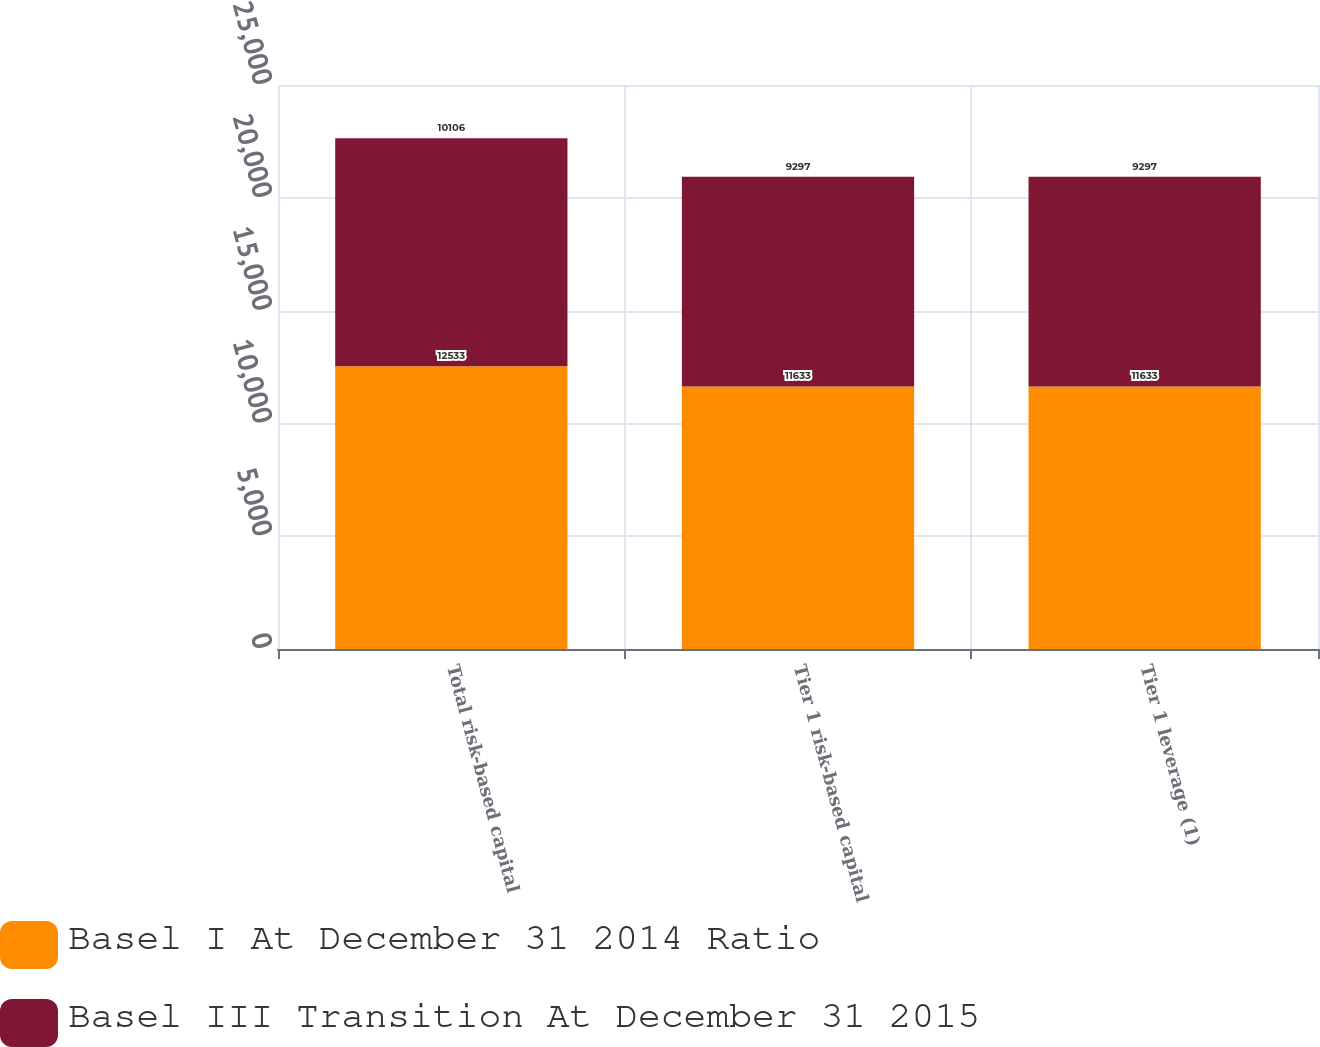Convert chart. <chart><loc_0><loc_0><loc_500><loc_500><stacked_bar_chart><ecel><fcel>Total risk-based capital<fcel>Tier 1 risk-based capital<fcel>Tier 1 leverage (1)<nl><fcel>Basel I At December 31 2014 Ratio<fcel>12533<fcel>11633<fcel>11633<nl><fcel>Basel III Transition At December 31 2015<fcel>10106<fcel>9297<fcel>9297<nl></chart> 